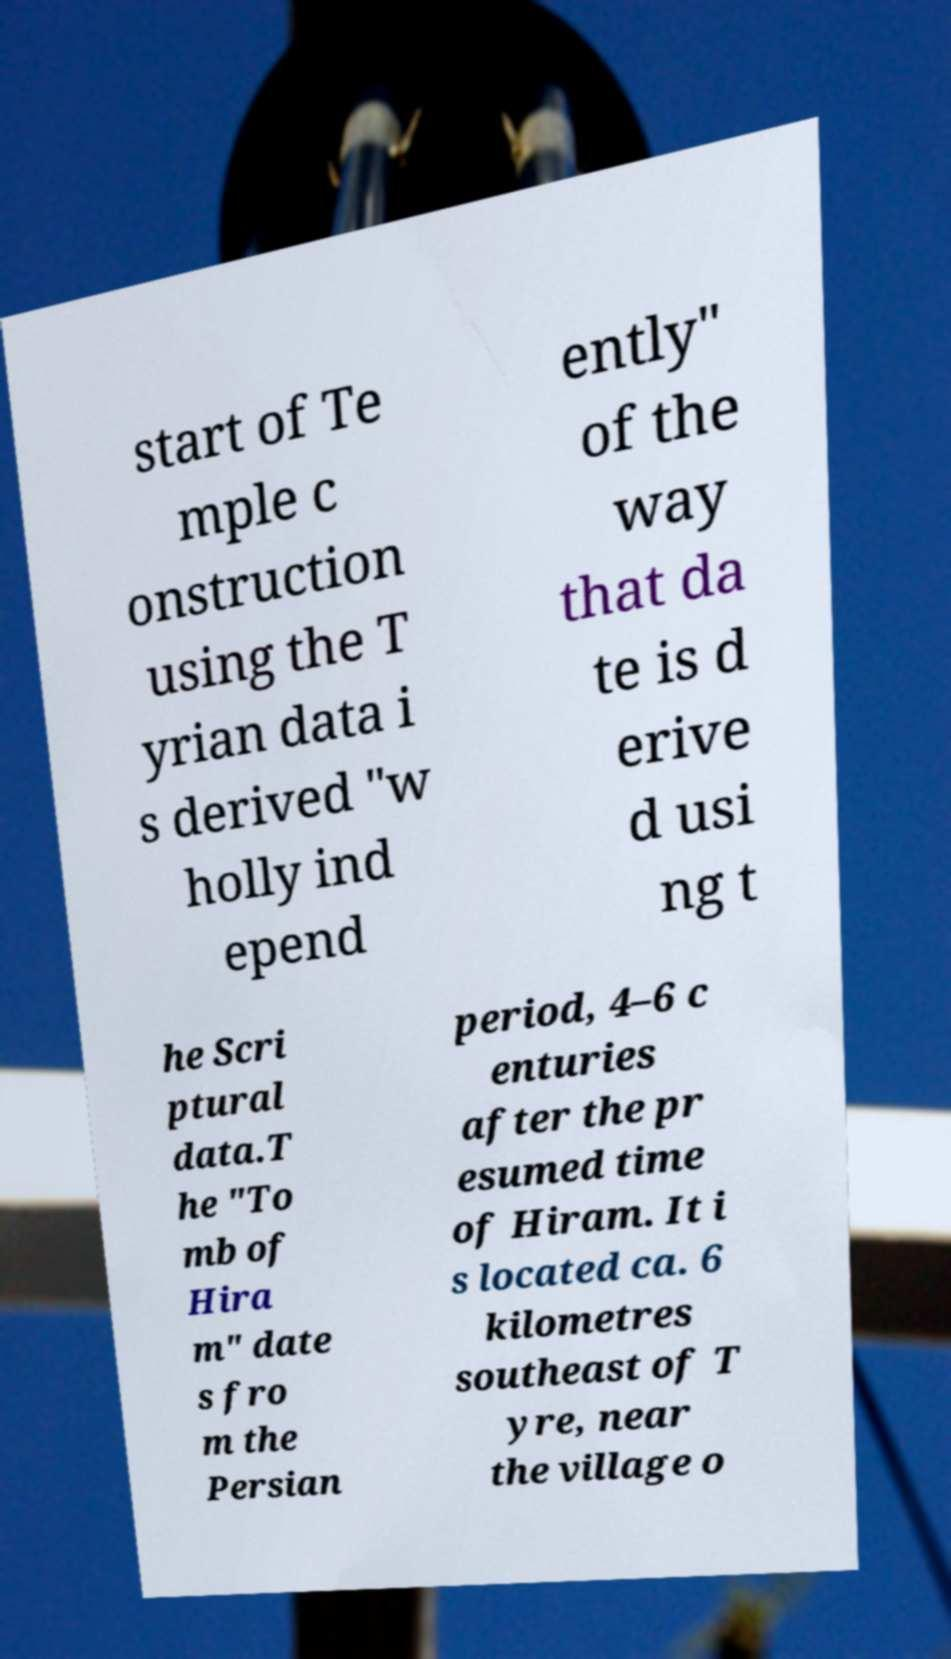Could you assist in decoding the text presented in this image and type it out clearly? start of Te mple c onstruction using the T yrian data i s derived "w holly ind epend ently" of the way that da te is d erive d usi ng t he Scri ptural data.T he "To mb of Hira m" date s fro m the Persian period, 4–6 c enturies after the pr esumed time of Hiram. It i s located ca. 6 kilometres southeast of T yre, near the village o 